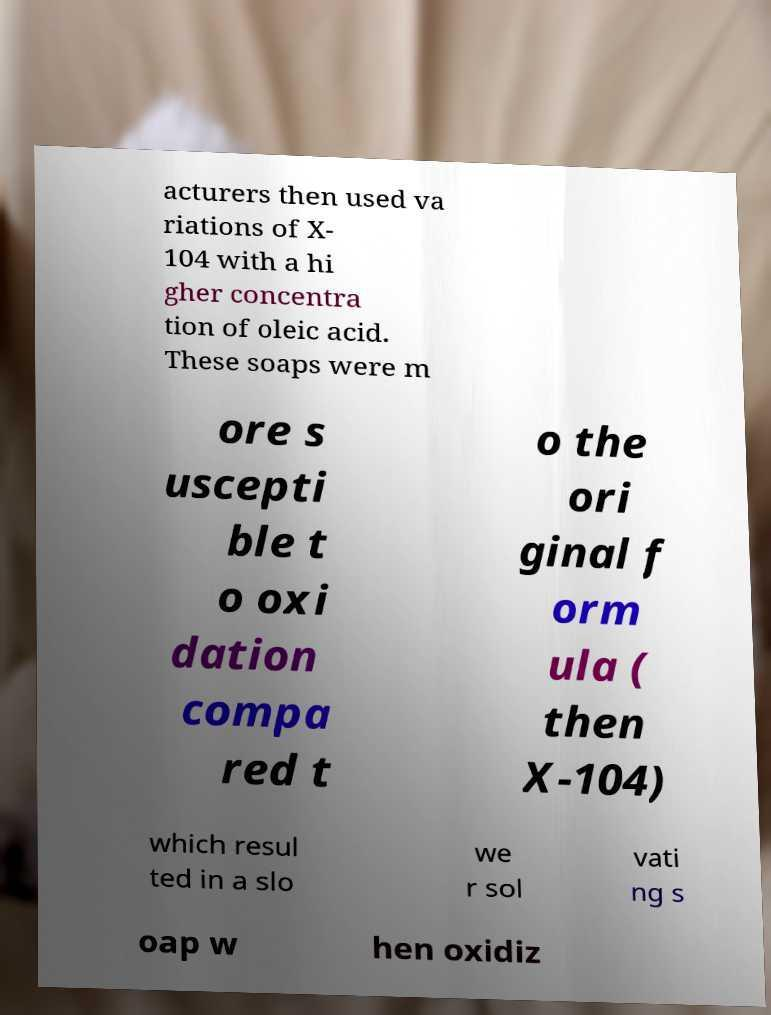For documentation purposes, I need the text within this image transcribed. Could you provide that? acturers then used va riations of X- 104 with a hi gher concentra tion of oleic acid. These soaps were m ore s uscepti ble t o oxi dation compa red t o the ori ginal f orm ula ( then X-104) which resul ted in a slo we r sol vati ng s oap w hen oxidiz 